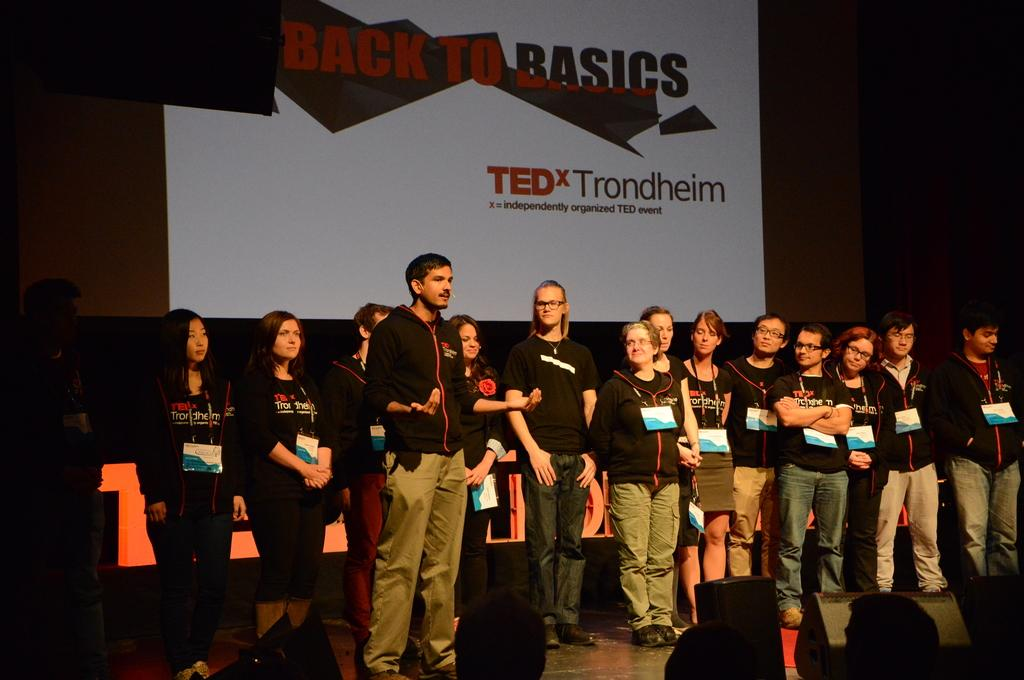What is happening in the image? There are people standing in the image. What can be seen in the background of the image? There is a screen in the background of the image. What is displayed on the screen? There is text visible on the screen. What are the people wearing that might help identify them? The people in the image are wearing tags. How does the manager use the grip to make a comparison in the image? There is no manager or grip present in the image, so it is not possible to answer that question. 